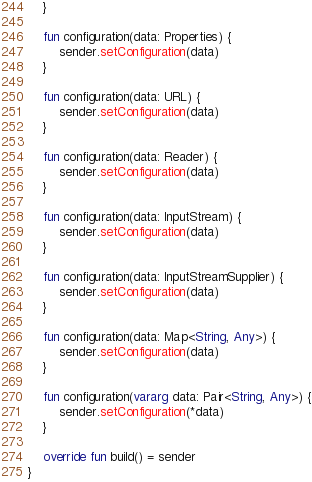<code> <loc_0><loc_0><loc_500><loc_500><_Kotlin_>    }

    fun configuration(data: Properties) {
        sender.setConfiguration(data)
    }

    fun configuration(data: URL) {
        sender.setConfiguration(data)
    }

    fun configuration(data: Reader) {
        sender.setConfiguration(data)
    }

    fun configuration(data: InputStream) {
        sender.setConfiguration(data)
    }

    fun configuration(data: InputStreamSupplier) {
        sender.setConfiguration(data)
    }

    fun configuration(data: Map<String, Any>) {
        sender.setConfiguration(data)
    }

    fun configuration(vararg data: Pair<String, Any>) {
        sender.setConfiguration(*data)
    }

    override fun build() = sender
}</code> 